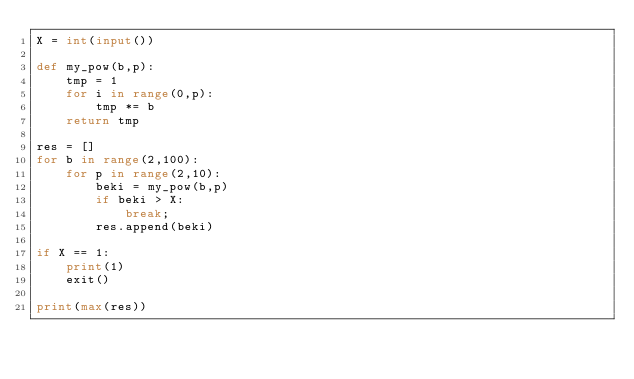<code> <loc_0><loc_0><loc_500><loc_500><_Python_>X = int(input())

def my_pow(b,p):
    tmp = 1
    for i in range(0,p):
        tmp *= b
    return tmp

res = []
for b in range(2,100):
    for p in range(2,10):
        beki = my_pow(b,p)
        if beki > X:
            break;
        res.append(beki)

if X == 1:
    print(1)
    exit()

print(max(res))
</code> 